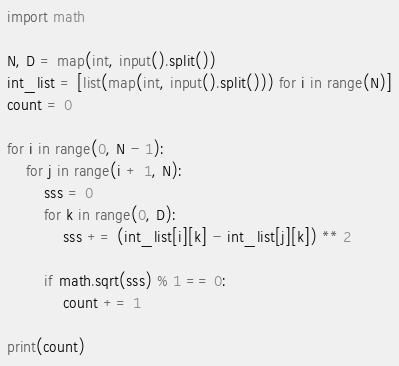<code> <loc_0><loc_0><loc_500><loc_500><_Python_>import math

N, D = map(int, input().split())
int_list = [list(map(int, input().split())) for i in range(N)]
count = 0

for i in range(0, N - 1):
    for j in range(i + 1, N):
        sss = 0
        for k in range(0, D):
            sss += (int_list[i][k] - int_list[j][k]) ** 2

        if math.sqrt(sss) % 1 == 0:
            count += 1

print(count)</code> 